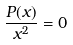<formula> <loc_0><loc_0><loc_500><loc_500>\frac { P ( x ) } { x ^ { 2 } } = 0</formula> 